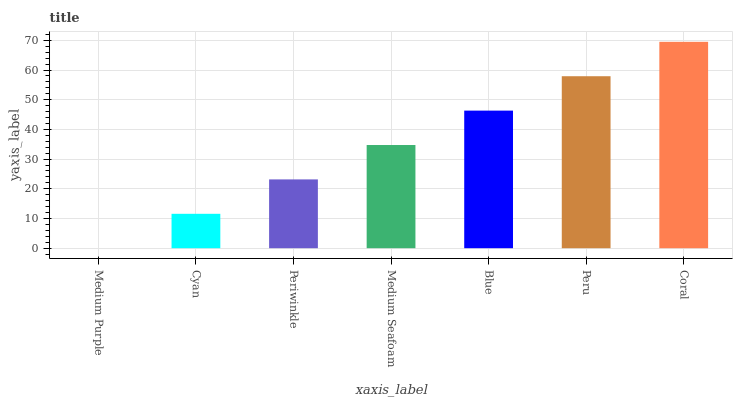Is Medium Purple the minimum?
Answer yes or no. Yes. Is Coral the maximum?
Answer yes or no. Yes. Is Cyan the minimum?
Answer yes or no. No. Is Cyan the maximum?
Answer yes or no. No. Is Cyan greater than Medium Purple?
Answer yes or no. Yes. Is Medium Purple less than Cyan?
Answer yes or no. Yes. Is Medium Purple greater than Cyan?
Answer yes or no. No. Is Cyan less than Medium Purple?
Answer yes or no. No. Is Medium Seafoam the high median?
Answer yes or no. Yes. Is Medium Seafoam the low median?
Answer yes or no. Yes. Is Peru the high median?
Answer yes or no. No. Is Periwinkle the low median?
Answer yes or no. No. 